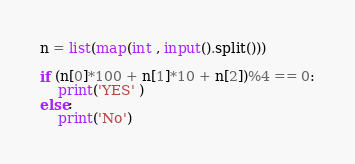<code> <loc_0><loc_0><loc_500><loc_500><_Python_>n = list(map(int , input().split()))

if (n[0]*100 + n[1]*10 + n[2])%4 == 0:
    print('YES' )
else:
    print('No')</code> 